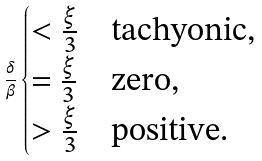Convert formula to latex. <formula><loc_0><loc_0><loc_500><loc_500>\frac { \delta } { \beta } \begin{cases} < \frac { \xi } { 3 } & \text {tachyonic,} \\ = \frac { \xi } { 3 } & \text {zero,} \\ > \frac { \xi } { 3 } & \text {positive.} \end{cases}</formula> 